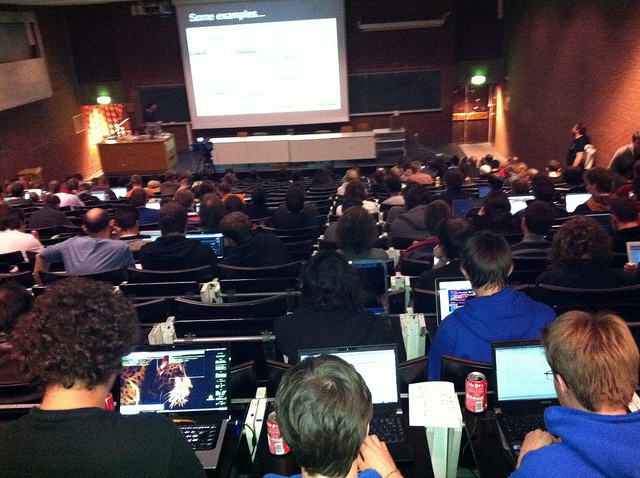Please transcribe the text information in this image. Same examples 